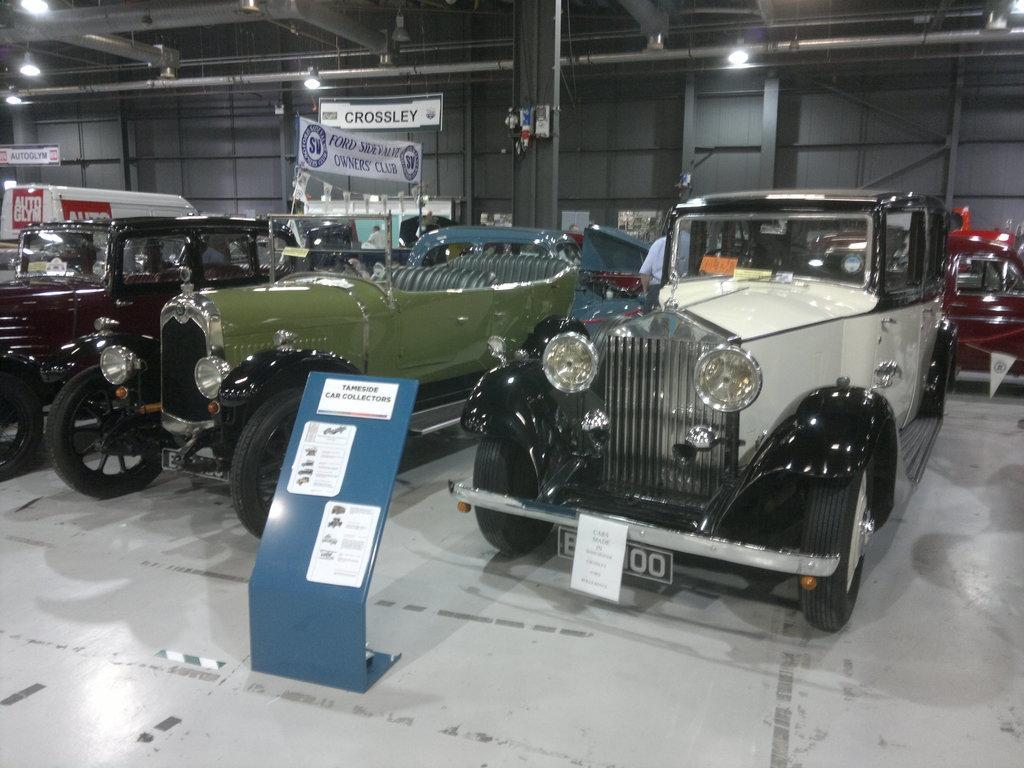Could you give a brief overview of what you see in this image? In this image we can see cars. In the background of the image there is wall. At the top of the image there is ceiling with lights and rods. There are banners with some text. In the foreground of the image there is a board with some text on it. At the bottom of the image there is floor. 